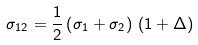Convert formula to latex. <formula><loc_0><loc_0><loc_500><loc_500>\sigma _ { 1 2 } = \frac { 1 } { 2 } \left ( \sigma _ { 1 } + \sigma _ { 2 } \right ) \, \left ( 1 + \Delta \right )</formula> 